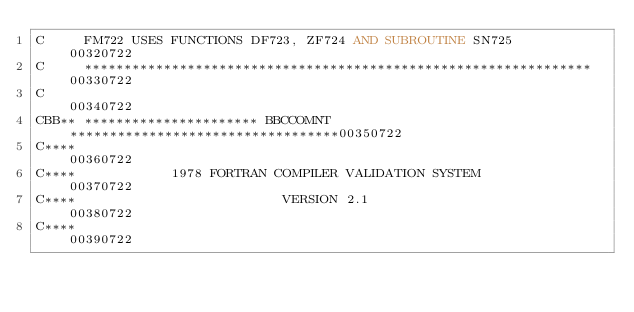Convert code to text. <code><loc_0><loc_0><loc_500><loc_500><_FORTRAN_>C     FM722 USES FUNCTIONS DF723, ZF724 AND SUBROUTINE SN725            00320722
C     ****************************************************************  00330722
C                                                                       00340722
CBB** ********************** BBCCOMNT **********************************00350722
C****                                                                   00360722
C****            1978 FORTRAN COMPILER VALIDATION SYSTEM                00370722
C****                          VERSION 2.1                              00380722
C****                                                                   00390722</code> 